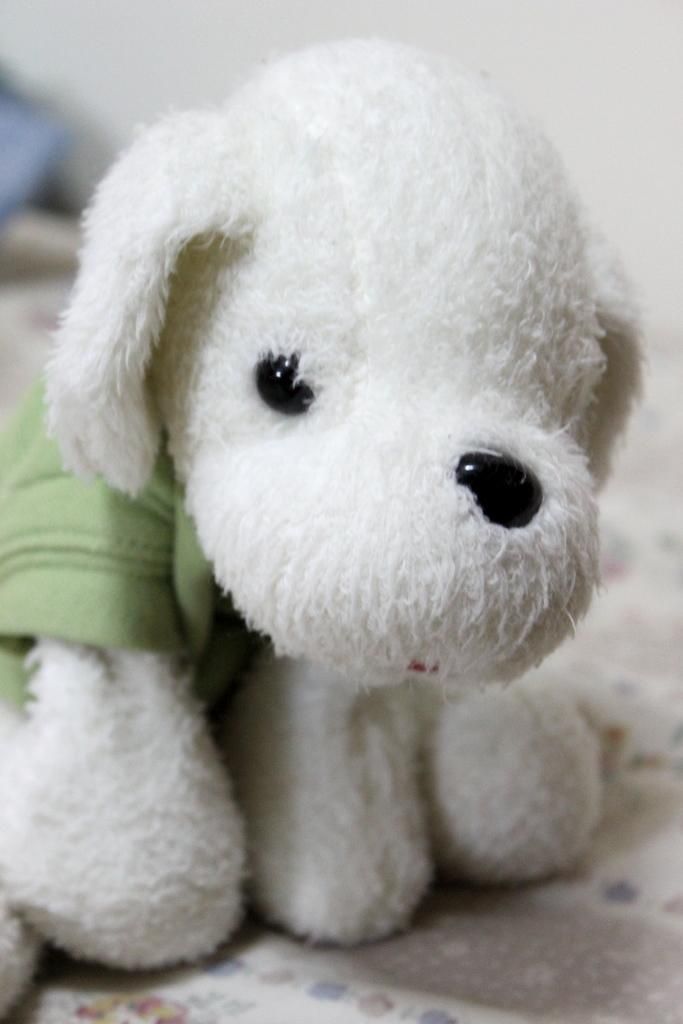What type of toy is present in the image? There is a toy in the image that resembles a dog. Can you describe the background of the image? The background of the image is blurred. What is located in the foreground of the image? There is a white cloth in the foreground of the image. How many planes are visible in the image? There are no planes visible in the image. What type of things are present on the cushion? There is no cushion present in the image. 